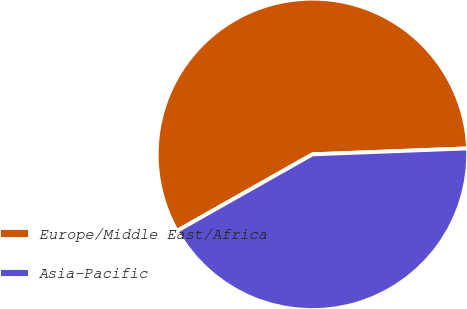Convert chart to OTSL. <chart><loc_0><loc_0><loc_500><loc_500><pie_chart><fcel>Europe/Middle East/Africa<fcel>Asia-Pacific<nl><fcel>57.58%<fcel>42.42%<nl></chart> 